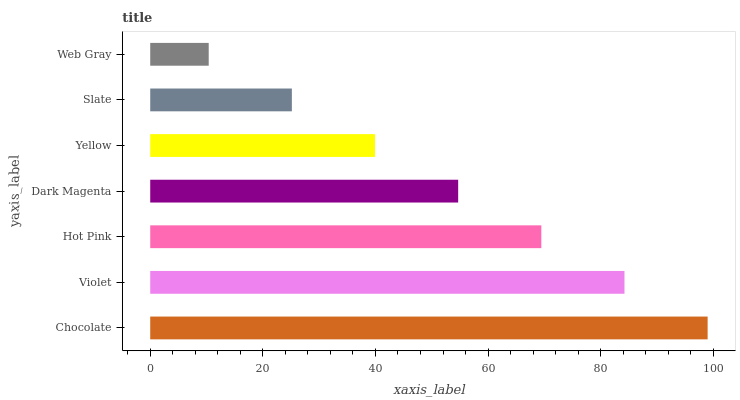Is Web Gray the minimum?
Answer yes or no. Yes. Is Chocolate the maximum?
Answer yes or no. Yes. Is Violet the minimum?
Answer yes or no. No. Is Violet the maximum?
Answer yes or no. No. Is Chocolate greater than Violet?
Answer yes or no. Yes. Is Violet less than Chocolate?
Answer yes or no. Yes. Is Violet greater than Chocolate?
Answer yes or no. No. Is Chocolate less than Violet?
Answer yes or no. No. Is Dark Magenta the high median?
Answer yes or no. Yes. Is Dark Magenta the low median?
Answer yes or no. Yes. Is Slate the high median?
Answer yes or no. No. Is Yellow the low median?
Answer yes or no. No. 